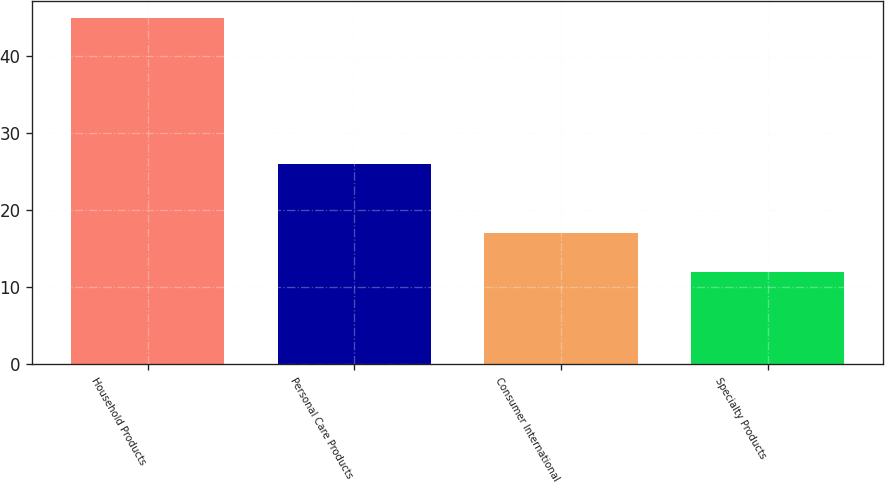Convert chart to OTSL. <chart><loc_0><loc_0><loc_500><loc_500><bar_chart><fcel>Household Products<fcel>Personal Care Products<fcel>Consumer International<fcel>Specialty Products<nl><fcel>45<fcel>26<fcel>17<fcel>12<nl></chart> 